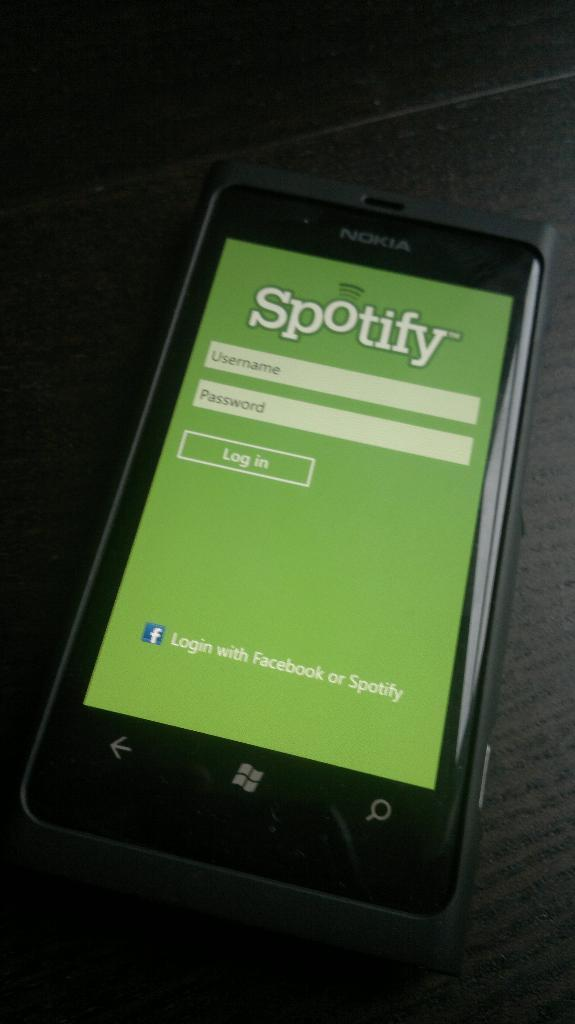Provide a one-sentence caption for the provided image. the spotify sign in page on a phone screen. 